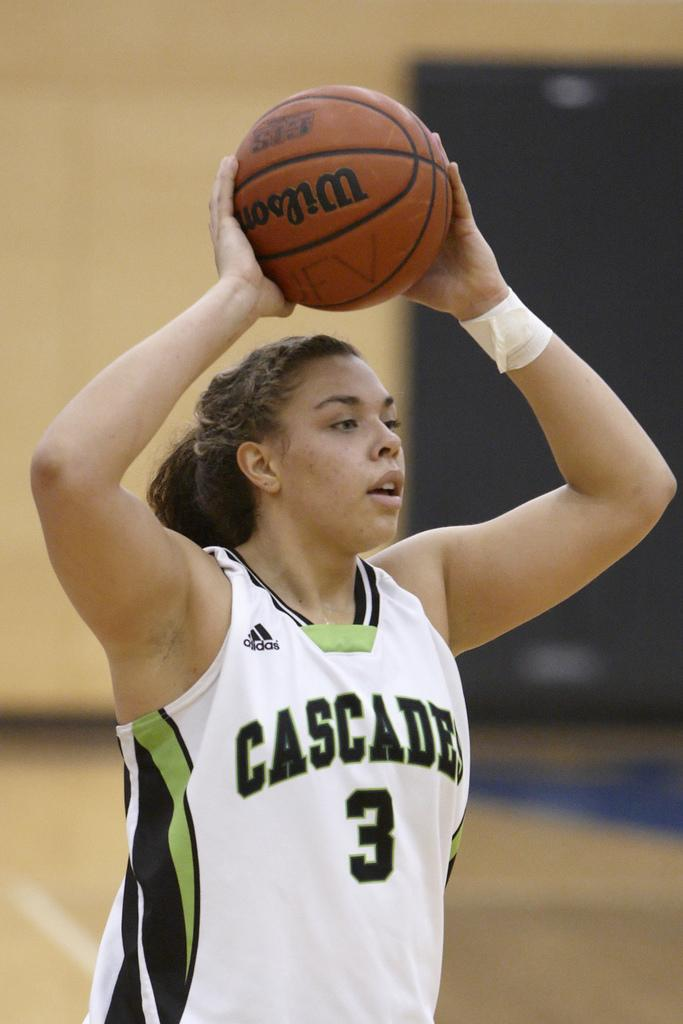<image>
Offer a succinct explanation of the picture presented. A girl on the Cascades basketball team holds a Wilson basketball over her head. 